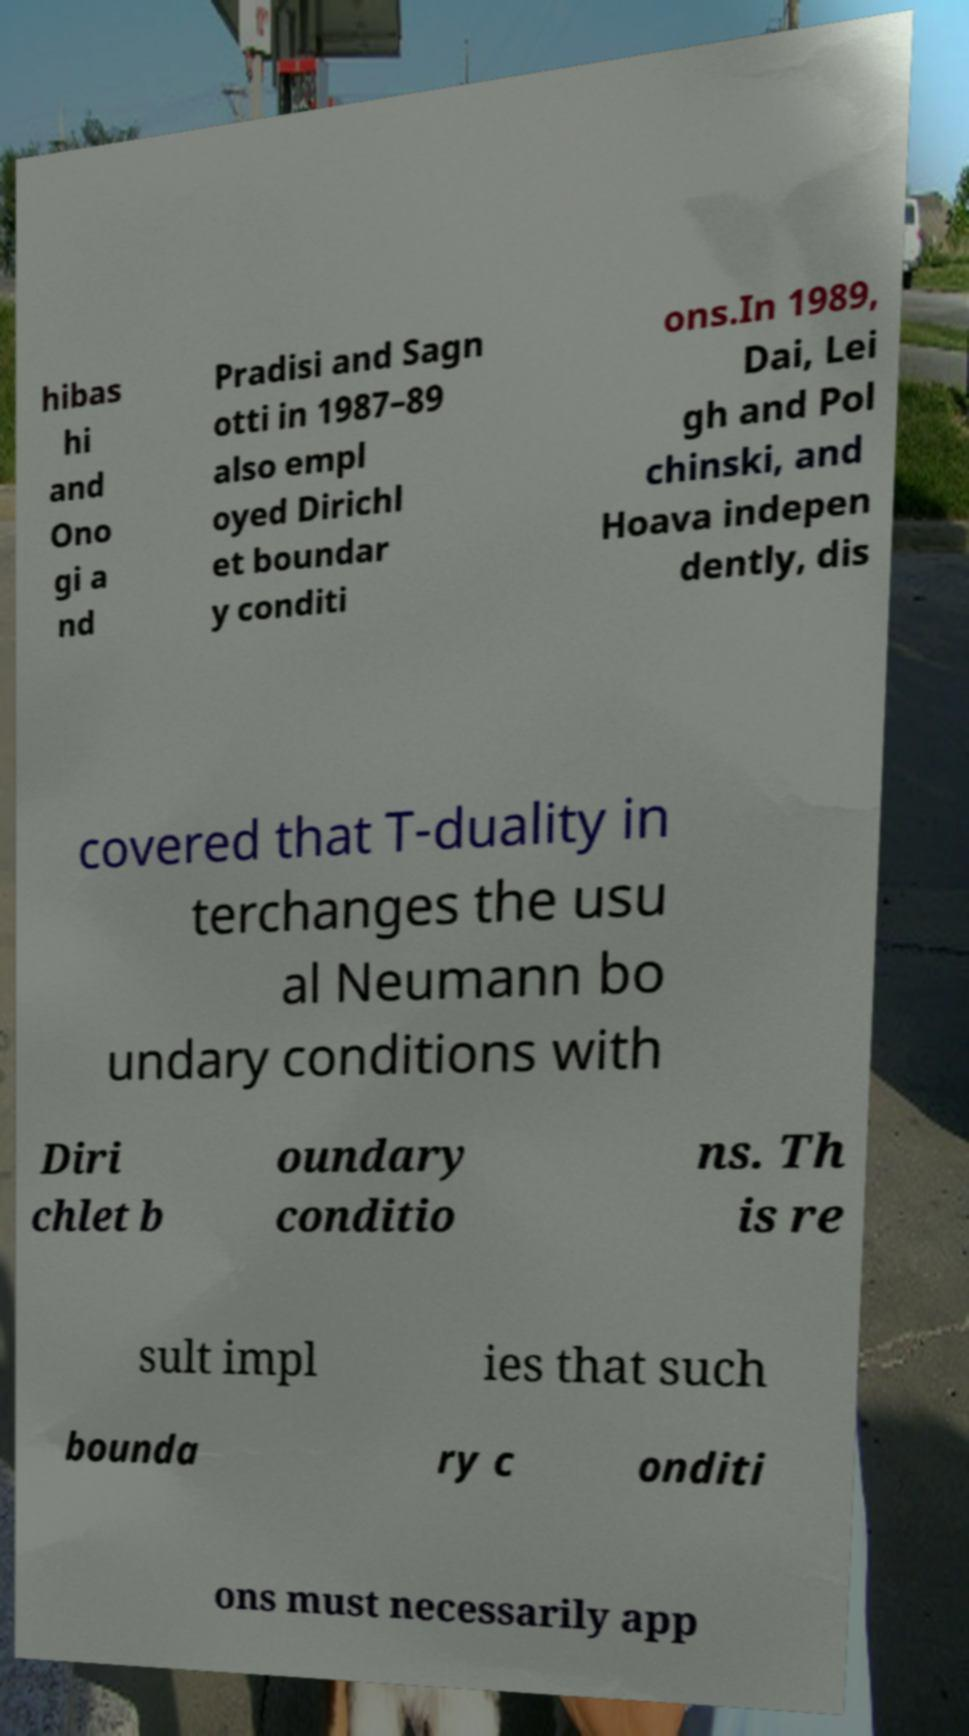Could you extract and type out the text from this image? hibas hi and Ono gi a nd Pradisi and Sagn otti in 1987–89 also empl oyed Dirichl et boundar y conditi ons.In 1989, Dai, Lei gh and Pol chinski, and Hoava indepen dently, dis covered that T-duality in terchanges the usu al Neumann bo undary conditions with Diri chlet b oundary conditio ns. Th is re sult impl ies that such bounda ry c onditi ons must necessarily app 